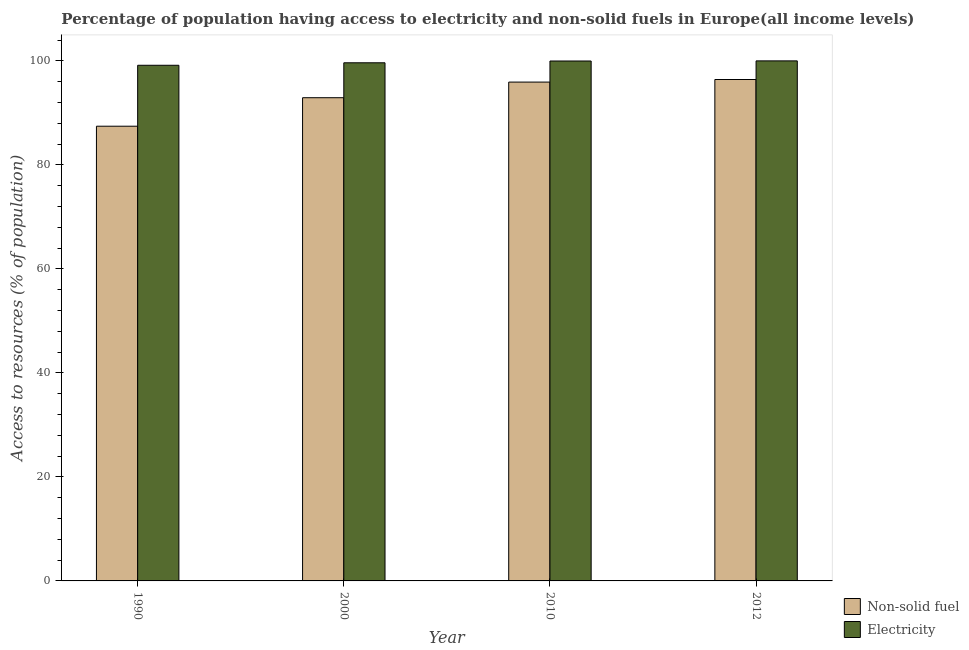How many groups of bars are there?
Give a very brief answer. 4. Are the number of bars per tick equal to the number of legend labels?
Provide a short and direct response. Yes. Are the number of bars on each tick of the X-axis equal?
Offer a very short reply. Yes. How many bars are there on the 4th tick from the left?
Provide a short and direct response. 2. How many bars are there on the 3rd tick from the right?
Offer a terse response. 2. What is the label of the 4th group of bars from the left?
Ensure brevity in your answer.  2012. What is the percentage of population having access to non-solid fuel in 1990?
Offer a terse response. 87.44. Across all years, what is the maximum percentage of population having access to electricity?
Your answer should be very brief. 100. Across all years, what is the minimum percentage of population having access to electricity?
Provide a short and direct response. 99.15. In which year was the percentage of population having access to non-solid fuel maximum?
Your answer should be compact. 2012. What is the total percentage of population having access to electricity in the graph?
Provide a short and direct response. 398.76. What is the difference between the percentage of population having access to electricity in 1990 and that in 2010?
Ensure brevity in your answer.  -0.82. What is the difference between the percentage of population having access to electricity in 1990 and the percentage of population having access to non-solid fuel in 2012?
Your answer should be compact. -0.85. What is the average percentage of population having access to non-solid fuel per year?
Your answer should be very brief. 93.17. In the year 2010, what is the difference between the percentage of population having access to non-solid fuel and percentage of population having access to electricity?
Ensure brevity in your answer.  0. In how many years, is the percentage of population having access to non-solid fuel greater than 12 %?
Your answer should be compact. 4. What is the ratio of the percentage of population having access to non-solid fuel in 2000 to that in 2012?
Ensure brevity in your answer.  0.96. Is the percentage of population having access to non-solid fuel in 1990 less than that in 2010?
Offer a very short reply. Yes. What is the difference between the highest and the second highest percentage of population having access to non-solid fuel?
Provide a succinct answer. 0.5. What is the difference between the highest and the lowest percentage of population having access to electricity?
Give a very brief answer. 0.85. What does the 1st bar from the left in 2000 represents?
Offer a very short reply. Non-solid fuel. What does the 1st bar from the right in 2012 represents?
Give a very brief answer. Electricity. What is the difference between two consecutive major ticks on the Y-axis?
Give a very brief answer. 20. What is the title of the graph?
Your response must be concise. Percentage of population having access to electricity and non-solid fuels in Europe(all income levels). What is the label or title of the X-axis?
Provide a short and direct response. Year. What is the label or title of the Y-axis?
Ensure brevity in your answer.  Access to resources (% of population). What is the Access to resources (% of population) of Non-solid fuel in 1990?
Keep it short and to the point. 87.44. What is the Access to resources (% of population) of Electricity in 1990?
Provide a succinct answer. 99.15. What is the Access to resources (% of population) of Non-solid fuel in 2000?
Offer a terse response. 92.92. What is the Access to resources (% of population) of Electricity in 2000?
Ensure brevity in your answer.  99.63. What is the Access to resources (% of population) of Non-solid fuel in 2010?
Make the answer very short. 95.92. What is the Access to resources (% of population) of Electricity in 2010?
Ensure brevity in your answer.  99.97. What is the Access to resources (% of population) in Non-solid fuel in 2012?
Your response must be concise. 96.42. What is the Access to resources (% of population) of Electricity in 2012?
Your response must be concise. 100. Across all years, what is the maximum Access to resources (% of population) of Non-solid fuel?
Your answer should be compact. 96.42. Across all years, what is the maximum Access to resources (% of population) of Electricity?
Offer a terse response. 100. Across all years, what is the minimum Access to resources (% of population) in Non-solid fuel?
Provide a succinct answer. 87.44. Across all years, what is the minimum Access to resources (% of population) of Electricity?
Provide a short and direct response. 99.15. What is the total Access to resources (% of population) in Non-solid fuel in the graph?
Your answer should be compact. 372.69. What is the total Access to resources (% of population) in Electricity in the graph?
Ensure brevity in your answer.  398.76. What is the difference between the Access to resources (% of population) of Non-solid fuel in 1990 and that in 2000?
Provide a short and direct response. -5.48. What is the difference between the Access to resources (% of population) in Electricity in 1990 and that in 2000?
Provide a succinct answer. -0.48. What is the difference between the Access to resources (% of population) of Non-solid fuel in 1990 and that in 2010?
Provide a succinct answer. -8.49. What is the difference between the Access to resources (% of population) in Electricity in 1990 and that in 2010?
Offer a very short reply. -0.82. What is the difference between the Access to resources (% of population) of Non-solid fuel in 1990 and that in 2012?
Your answer should be compact. -8.98. What is the difference between the Access to resources (% of population) of Electricity in 1990 and that in 2012?
Provide a succinct answer. -0.85. What is the difference between the Access to resources (% of population) in Non-solid fuel in 2000 and that in 2010?
Offer a very short reply. -3.01. What is the difference between the Access to resources (% of population) of Electricity in 2000 and that in 2010?
Your answer should be very brief. -0.34. What is the difference between the Access to resources (% of population) of Non-solid fuel in 2000 and that in 2012?
Offer a very short reply. -3.5. What is the difference between the Access to resources (% of population) of Electricity in 2000 and that in 2012?
Your response must be concise. -0.37. What is the difference between the Access to resources (% of population) of Non-solid fuel in 2010 and that in 2012?
Ensure brevity in your answer.  -0.5. What is the difference between the Access to resources (% of population) of Electricity in 2010 and that in 2012?
Offer a terse response. -0.03. What is the difference between the Access to resources (% of population) in Non-solid fuel in 1990 and the Access to resources (% of population) in Electricity in 2000?
Make the answer very short. -12.2. What is the difference between the Access to resources (% of population) of Non-solid fuel in 1990 and the Access to resources (% of population) of Electricity in 2010?
Provide a succinct answer. -12.54. What is the difference between the Access to resources (% of population) in Non-solid fuel in 1990 and the Access to resources (% of population) in Electricity in 2012?
Your answer should be compact. -12.56. What is the difference between the Access to resources (% of population) of Non-solid fuel in 2000 and the Access to resources (% of population) of Electricity in 2010?
Offer a very short reply. -7.06. What is the difference between the Access to resources (% of population) in Non-solid fuel in 2000 and the Access to resources (% of population) in Electricity in 2012?
Make the answer very short. -7.08. What is the difference between the Access to resources (% of population) of Non-solid fuel in 2010 and the Access to resources (% of population) of Electricity in 2012?
Keep it short and to the point. -4.08. What is the average Access to resources (% of population) in Non-solid fuel per year?
Your answer should be very brief. 93.17. What is the average Access to resources (% of population) in Electricity per year?
Your response must be concise. 99.69. In the year 1990, what is the difference between the Access to resources (% of population) of Non-solid fuel and Access to resources (% of population) of Electricity?
Provide a succinct answer. -11.72. In the year 2000, what is the difference between the Access to resources (% of population) of Non-solid fuel and Access to resources (% of population) of Electricity?
Your response must be concise. -6.72. In the year 2010, what is the difference between the Access to resources (% of population) of Non-solid fuel and Access to resources (% of population) of Electricity?
Give a very brief answer. -4.05. In the year 2012, what is the difference between the Access to resources (% of population) of Non-solid fuel and Access to resources (% of population) of Electricity?
Give a very brief answer. -3.58. What is the ratio of the Access to resources (% of population) of Non-solid fuel in 1990 to that in 2000?
Make the answer very short. 0.94. What is the ratio of the Access to resources (% of population) in Electricity in 1990 to that in 2000?
Ensure brevity in your answer.  1. What is the ratio of the Access to resources (% of population) of Non-solid fuel in 1990 to that in 2010?
Make the answer very short. 0.91. What is the ratio of the Access to resources (% of population) in Electricity in 1990 to that in 2010?
Your answer should be compact. 0.99. What is the ratio of the Access to resources (% of population) in Non-solid fuel in 1990 to that in 2012?
Give a very brief answer. 0.91. What is the ratio of the Access to resources (% of population) of Non-solid fuel in 2000 to that in 2010?
Offer a terse response. 0.97. What is the ratio of the Access to resources (% of population) in Non-solid fuel in 2000 to that in 2012?
Offer a terse response. 0.96. What is the ratio of the Access to resources (% of population) in Electricity in 2000 to that in 2012?
Your answer should be very brief. 1. What is the difference between the highest and the second highest Access to resources (% of population) of Non-solid fuel?
Offer a terse response. 0.5. What is the difference between the highest and the second highest Access to resources (% of population) of Electricity?
Keep it short and to the point. 0.03. What is the difference between the highest and the lowest Access to resources (% of population) of Non-solid fuel?
Provide a short and direct response. 8.98. What is the difference between the highest and the lowest Access to resources (% of population) of Electricity?
Provide a short and direct response. 0.85. 